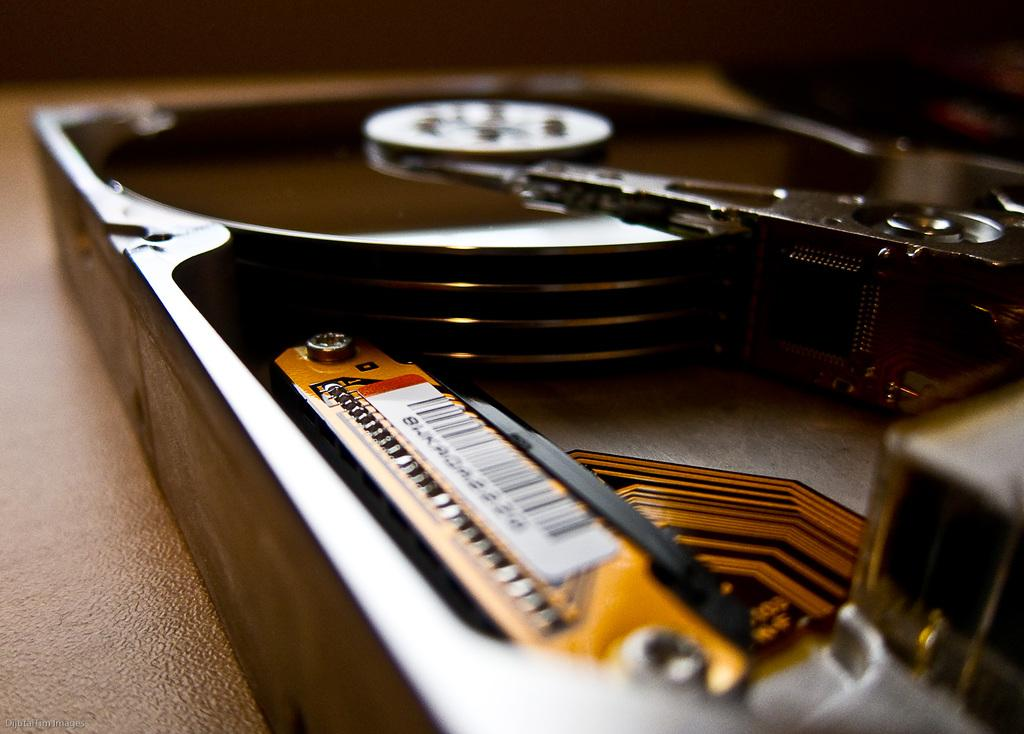What object is present in the image that is related to music? There is a music player in the image. Where is the music player located? The music player is on a table. What type of account is being managed by the music player in the image? There is no account being managed by the music player in the image; it is a device for playing music. 